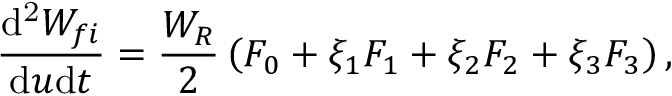<formula> <loc_0><loc_0><loc_500><loc_500>\frac { d ^ { 2 } W _ { f i } } { d u d t } = \frac { W _ { R } } { 2 } \left ( F _ { 0 } + \xi _ { 1 } F _ { 1 } + \xi _ { 2 } F _ { 2 } + \xi _ { 3 } F _ { 3 } \right ) ,</formula> 